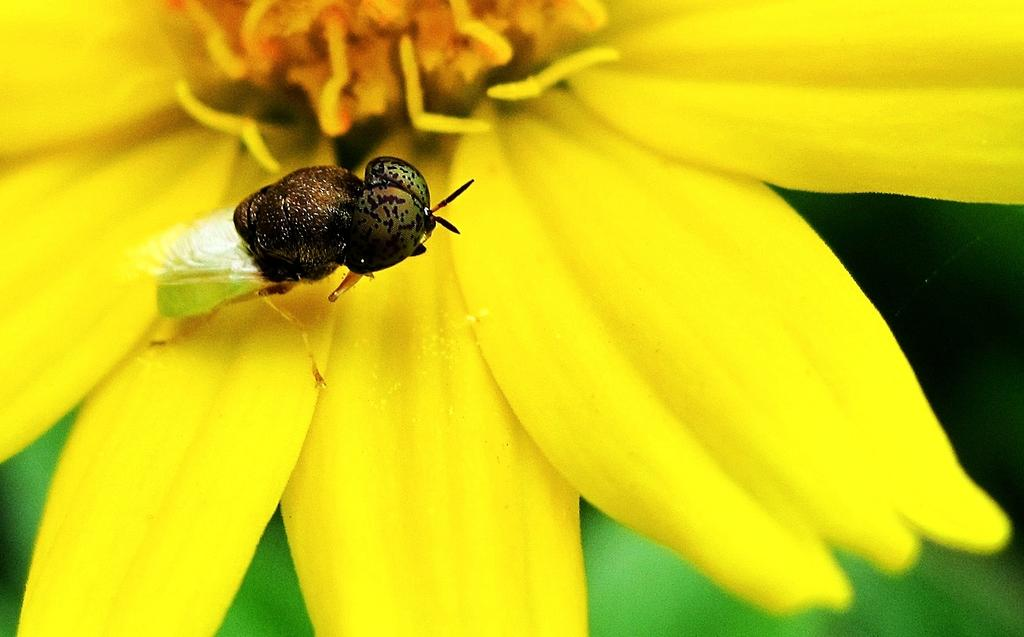What is the insect sitting on in the image? There is an insect on a yellow flower in the image. Can you describe the background of the image? The background is blurred in the image. What type of yarn is being used to create the class in the image? There is no class or yarn present in the image; it features an insect on a yellow flower with a blurred background. 